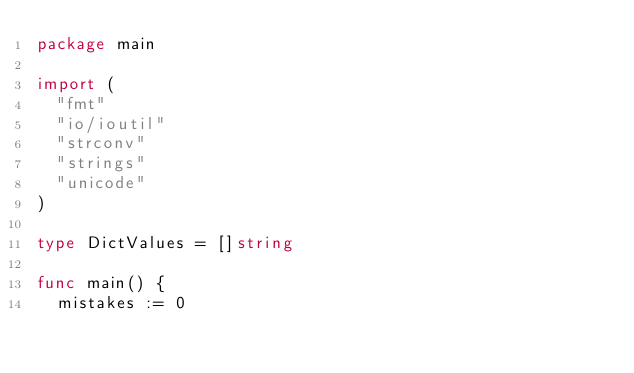<code> <loc_0><loc_0><loc_500><loc_500><_Go_>package main

import (
	"fmt"
	"io/ioutil"
	"strconv"
	"strings"
	"unicode"
)

type DictValues = []string

func main() {
	mistakes := 0</code> 